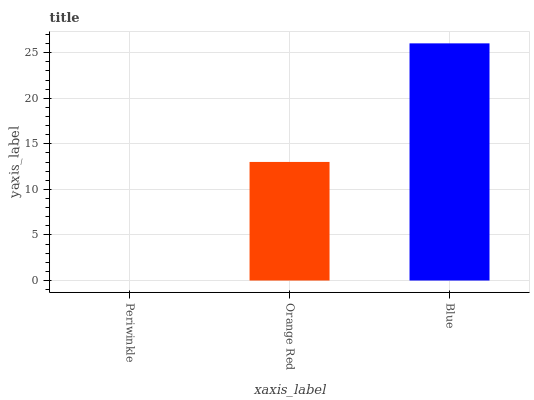Is Orange Red the minimum?
Answer yes or no. No. Is Orange Red the maximum?
Answer yes or no. No. Is Orange Red greater than Periwinkle?
Answer yes or no. Yes. Is Periwinkle less than Orange Red?
Answer yes or no. Yes. Is Periwinkle greater than Orange Red?
Answer yes or no. No. Is Orange Red less than Periwinkle?
Answer yes or no. No. Is Orange Red the high median?
Answer yes or no. Yes. Is Orange Red the low median?
Answer yes or no. Yes. Is Blue the high median?
Answer yes or no. No. Is Blue the low median?
Answer yes or no. No. 